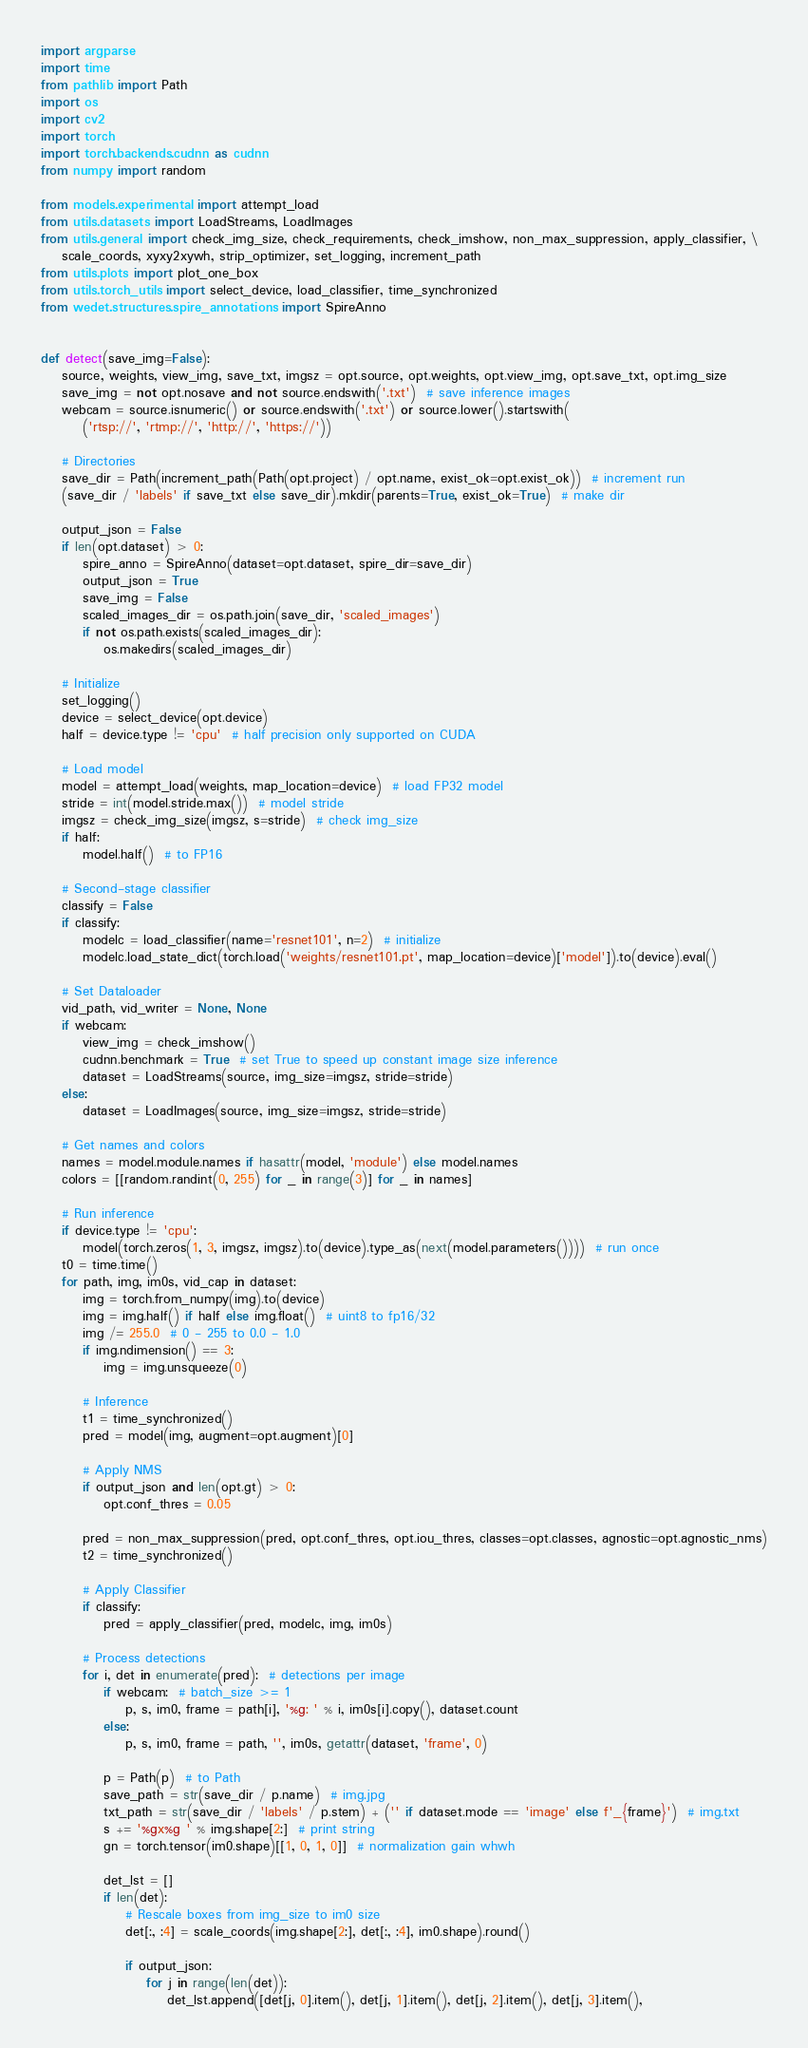Convert code to text. <code><loc_0><loc_0><loc_500><loc_500><_Python_>import argparse
import time
from pathlib import Path
import os
import cv2
import torch
import torch.backends.cudnn as cudnn
from numpy import random

from models.experimental import attempt_load
from utils.datasets import LoadStreams, LoadImages
from utils.general import check_img_size, check_requirements, check_imshow, non_max_suppression, apply_classifier, \
    scale_coords, xyxy2xywh, strip_optimizer, set_logging, increment_path
from utils.plots import plot_one_box
from utils.torch_utils import select_device, load_classifier, time_synchronized
from wedet.structures.spire_annotations import SpireAnno


def detect(save_img=False):
    source, weights, view_img, save_txt, imgsz = opt.source, opt.weights, opt.view_img, opt.save_txt, opt.img_size
    save_img = not opt.nosave and not source.endswith('.txt')  # save inference images
    webcam = source.isnumeric() or source.endswith('.txt') or source.lower().startswith(
        ('rtsp://', 'rtmp://', 'http://', 'https://'))

    # Directories
    save_dir = Path(increment_path(Path(opt.project) / opt.name, exist_ok=opt.exist_ok))  # increment run
    (save_dir / 'labels' if save_txt else save_dir).mkdir(parents=True, exist_ok=True)  # make dir

    output_json = False
    if len(opt.dataset) > 0:
        spire_anno = SpireAnno(dataset=opt.dataset, spire_dir=save_dir)
        output_json = True
        save_img = False
        scaled_images_dir = os.path.join(save_dir, 'scaled_images')
        if not os.path.exists(scaled_images_dir):
            os.makedirs(scaled_images_dir)

    # Initialize
    set_logging()
    device = select_device(opt.device)
    half = device.type != 'cpu'  # half precision only supported on CUDA

    # Load model
    model = attempt_load(weights, map_location=device)  # load FP32 model
    stride = int(model.stride.max())  # model stride
    imgsz = check_img_size(imgsz, s=stride)  # check img_size
    if half:
        model.half()  # to FP16

    # Second-stage classifier
    classify = False
    if classify:
        modelc = load_classifier(name='resnet101', n=2)  # initialize
        modelc.load_state_dict(torch.load('weights/resnet101.pt', map_location=device)['model']).to(device).eval()

    # Set Dataloader
    vid_path, vid_writer = None, None
    if webcam:
        view_img = check_imshow()
        cudnn.benchmark = True  # set True to speed up constant image size inference
        dataset = LoadStreams(source, img_size=imgsz, stride=stride)
    else:
        dataset = LoadImages(source, img_size=imgsz, stride=stride)

    # Get names and colors
    names = model.module.names if hasattr(model, 'module') else model.names
    colors = [[random.randint(0, 255) for _ in range(3)] for _ in names]

    # Run inference
    if device.type != 'cpu':
        model(torch.zeros(1, 3, imgsz, imgsz).to(device).type_as(next(model.parameters())))  # run once
    t0 = time.time()
    for path, img, im0s, vid_cap in dataset:
        img = torch.from_numpy(img).to(device)
        img = img.half() if half else img.float()  # uint8 to fp16/32
        img /= 255.0  # 0 - 255 to 0.0 - 1.0
        if img.ndimension() == 3:
            img = img.unsqueeze(0)

        # Inference
        t1 = time_synchronized()
        pred = model(img, augment=opt.augment)[0]

        # Apply NMS
        if output_json and len(opt.gt) > 0:
            opt.conf_thres = 0.05

        pred = non_max_suppression(pred, opt.conf_thres, opt.iou_thres, classes=opt.classes, agnostic=opt.agnostic_nms)
        t2 = time_synchronized()

        # Apply Classifier
        if classify:
            pred = apply_classifier(pred, modelc, img, im0s)

        # Process detections
        for i, det in enumerate(pred):  # detections per image
            if webcam:  # batch_size >= 1
                p, s, im0, frame = path[i], '%g: ' % i, im0s[i].copy(), dataset.count
            else:
                p, s, im0, frame = path, '', im0s, getattr(dataset, 'frame', 0)

            p = Path(p)  # to Path
            save_path = str(save_dir / p.name)  # img.jpg
            txt_path = str(save_dir / 'labels' / p.stem) + ('' if dataset.mode == 'image' else f'_{frame}')  # img.txt
            s += '%gx%g ' % img.shape[2:]  # print string
            gn = torch.tensor(im0.shape)[[1, 0, 1, 0]]  # normalization gain whwh

            det_lst = []
            if len(det):
                # Rescale boxes from img_size to im0 size
                det[:, :4] = scale_coords(img.shape[2:], det[:, :4], im0.shape).round()

                if output_json:
                    for j in range(len(det)):
                        det_lst.append([det[j, 0].item(), det[j, 1].item(), det[j, 2].item(), det[j, 3].item(),</code> 